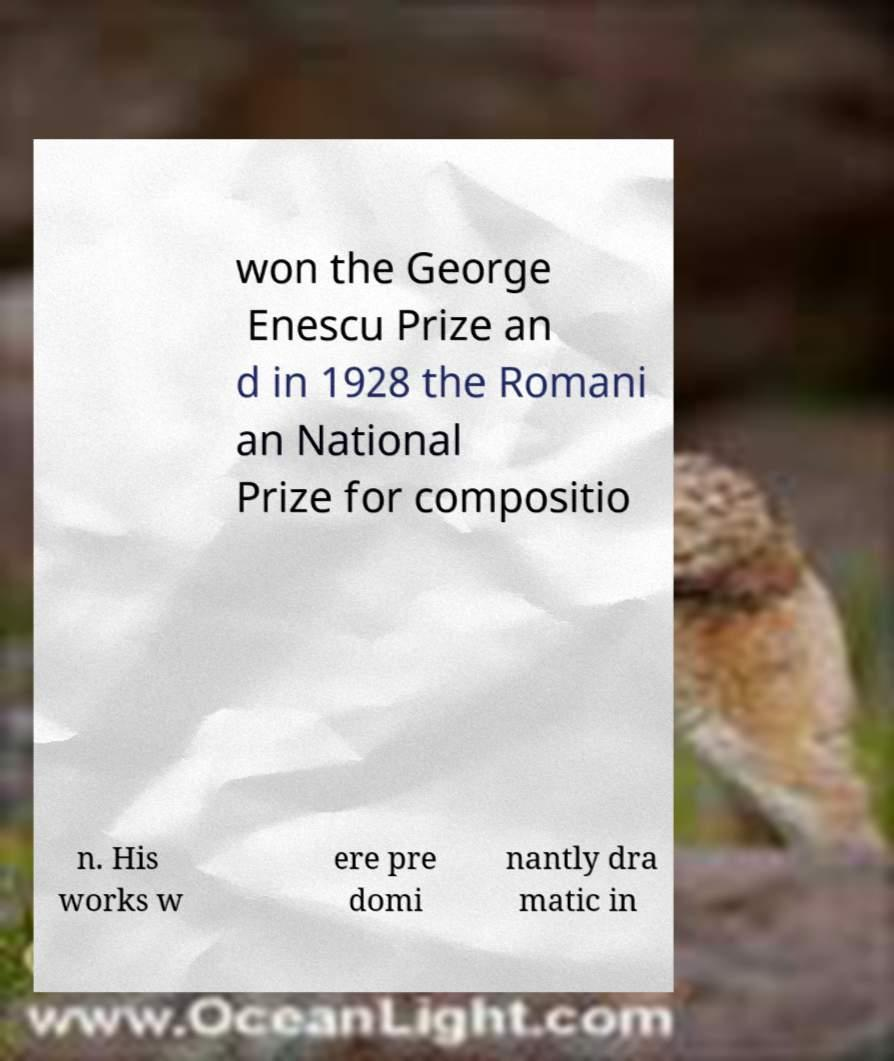Please identify and transcribe the text found in this image. won the George Enescu Prize an d in 1928 the Romani an National Prize for compositio n. His works w ere pre domi nantly dra matic in 